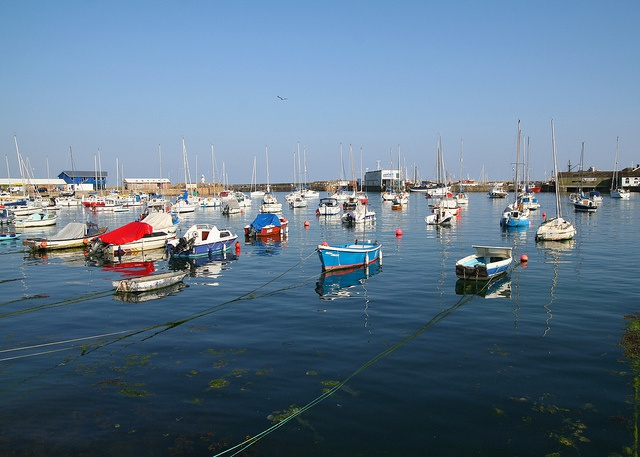Describe the objects in this image and their specific colors. I can see boat in gray, lightgray, darkgray, and black tones, boat in gray, red, ivory, and black tones, boat in gray, teal, and white tones, boat in gray, white, black, and darkgray tones, and boat in gray, black, ivory, and darkgray tones in this image. 